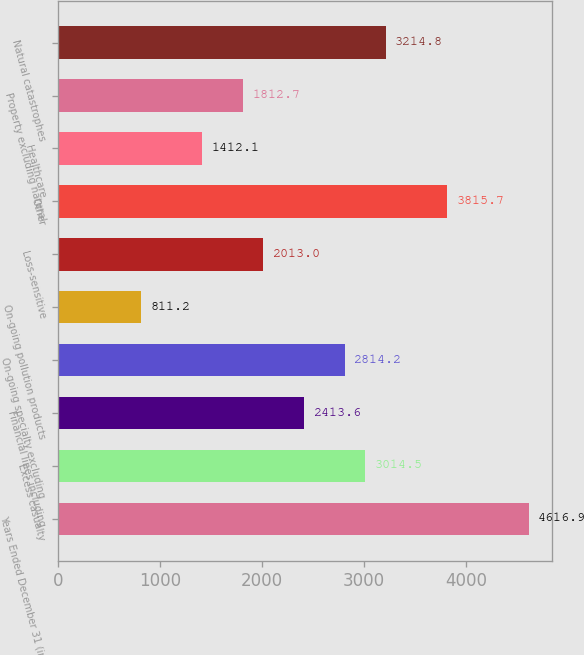Convert chart to OTSL. <chart><loc_0><loc_0><loc_500><loc_500><bar_chart><fcel>Years Ended December 31 (in<fcel>Excess casualty<fcel>Financial lines including<fcel>On-going specialty excluding<fcel>On-going pollution products<fcel>Loss-sensitive<fcel>Other<fcel>Healthcare<fcel>Property excluding natural<fcel>Natural catastrophes<nl><fcel>4616.9<fcel>3014.5<fcel>2413.6<fcel>2814.2<fcel>811.2<fcel>2013<fcel>3815.7<fcel>1412.1<fcel>1812.7<fcel>3214.8<nl></chart> 